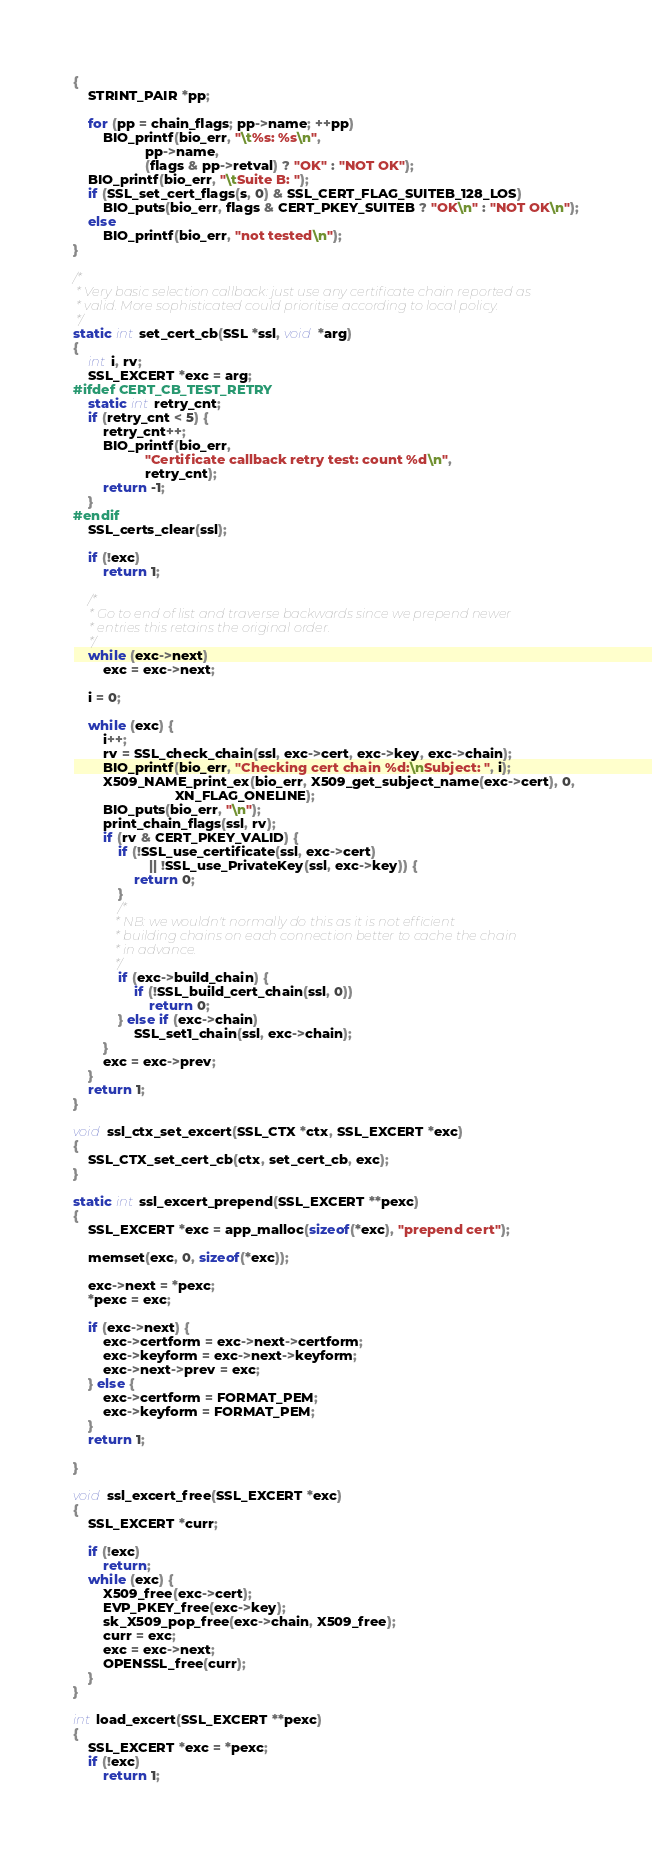<code> <loc_0><loc_0><loc_500><loc_500><_C_>{
    STRINT_PAIR *pp;

    for (pp = chain_flags; pp->name; ++pp)
        BIO_printf(bio_err, "\t%s: %s\n",
                   pp->name,
                   (flags & pp->retval) ? "OK" : "NOT OK");
    BIO_printf(bio_err, "\tSuite B: ");
    if (SSL_set_cert_flags(s, 0) & SSL_CERT_FLAG_SUITEB_128_LOS)
        BIO_puts(bio_err, flags & CERT_PKEY_SUITEB ? "OK\n" : "NOT OK\n");
    else
        BIO_printf(bio_err, "not tested\n");
}

/*
 * Very basic selection callback: just use any certificate chain reported as
 * valid. More sophisticated could prioritise according to local policy.
 */
static int set_cert_cb(SSL *ssl, void *arg)
{
    int i, rv;
    SSL_EXCERT *exc = arg;
#ifdef CERT_CB_TEST_RETRY
    static int retry_cnt;
    if (retry_cnt < 5) {
        retry_cnt++;
        BIO_printf(bio_err,
                   "Certificate callback retry test: count %d\n",
                   retry_cnt);
        return -1;
    }
#endif
    SSL_certs_clear(ssl);

    if (!exc)
        return 1;

    /*
     * Go to end of list and traverse backwards since we prepend newer
     * entries this retains the original order.
     */
    while (exc->next)
        exc = exc->next;

    i = 0;

    while (exc) {
        i++;
        rv = SSL_check_chain(ssl, exc->cert, exc->key, exc->chain);
        BIO_printf(bio_err, "Checking cert chain %d:\nSubject: ", i);
        X509_NAME_print_ex(bio_err, X509_get_subject_name(exc->cert), 0,
                           XN_FLAG_ONELINE);
        BIO_puts(bio_err, "\n");
        print_chain_flags(ssl, rv);
        if (rv & CERT_PKEY_VALID) {
            if (!SSL_use_certificate(ssl, exc->cert)
                    || !SSL_use_PrivateKey(ssl, exc->key)) {
                return 0;
            }
            /*
             * NB: we wouldn't normally do this as it is not efficient
             * building chains on each connection better to cache the chain
             * in advance.
             */
            if (exc->build_chain) {
                if (!SSL_build_cert_chain(ssl, 0))
                    return 0;
            } else if (exc->chain)
                SSL_set1_chain(ssl, exc->chain);
        }
        exc = exc->prev;
    }
    return 1;
}

void ssl_ctx_set_excert(SSL_CTX *ctx, SSL_EXCERT *exc)
{
    SSL_CTX_set_cert_cb(ctx, set_cert_cb, exc);
}

static int ssl_excert_prepend(SSL_EXCERT **pexc)
{
    SSL_EXCERT *exc = app_malloc(sizeof(*exc), "prepend cert");

    memset(exc, 0, sizeof(*exc));

    exc->next = *pexc;
    *pexc = exc;

    if (exc->next) {
        exc->certform = exc->next->certform;
        exc->keyform = exc->next->keyform;
        exc->next->prev = exc;
    } else {
        exc->certform = FORMAT_PEM;
        exc->keyform = FORMAT_PEM;
    }
    return 1;

}

void ssl_excert_free(SSL_EXCERT *exc)
{
    SSL_EXCERT *curr;

    if (!exc)
        return;
    while (exc) {
        X509_free(exc->cert);
        EVP_PKEY_free(exc->key);
        sk_X509_pop_free(exc->chain, X509_free);
        curr = exc;
        exc = exc->next;
        OPENSSL_free(curr);
    }
}

int load_excert(SSL_EXCERT **pexc)
{
    SSL_EXCERT *exc = *pexc;
    if (!exc)
        return 1;</code> 